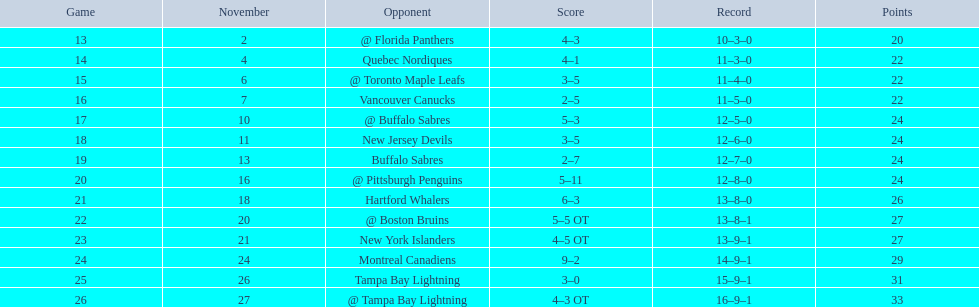What were the points? @ Florida Panthers, 4–3, Quebec Nordiques, 4–1, @ Toronto Maple Leafs, 3–5, Vancouver Canucks, 2–5, @ Buffalo Sabres, 5–3, New Jersey Devils, 3–5, Buffalo Sabres, 2–7, @ Pittsburgh Penguins, 5–11, Hartford Whalers, 6–3, @ Boston Bruins, 5–5 OT, New York Islanders, 4–5 OT, Montreal Canadiens, 9–2, Tampa Bay Lightning, 3–0, @ Tampa Bay Lightning, 4–3 OT. Which point was the closest? New York Islanders, 4–5 OT. What team had that point? New York Islanders. 